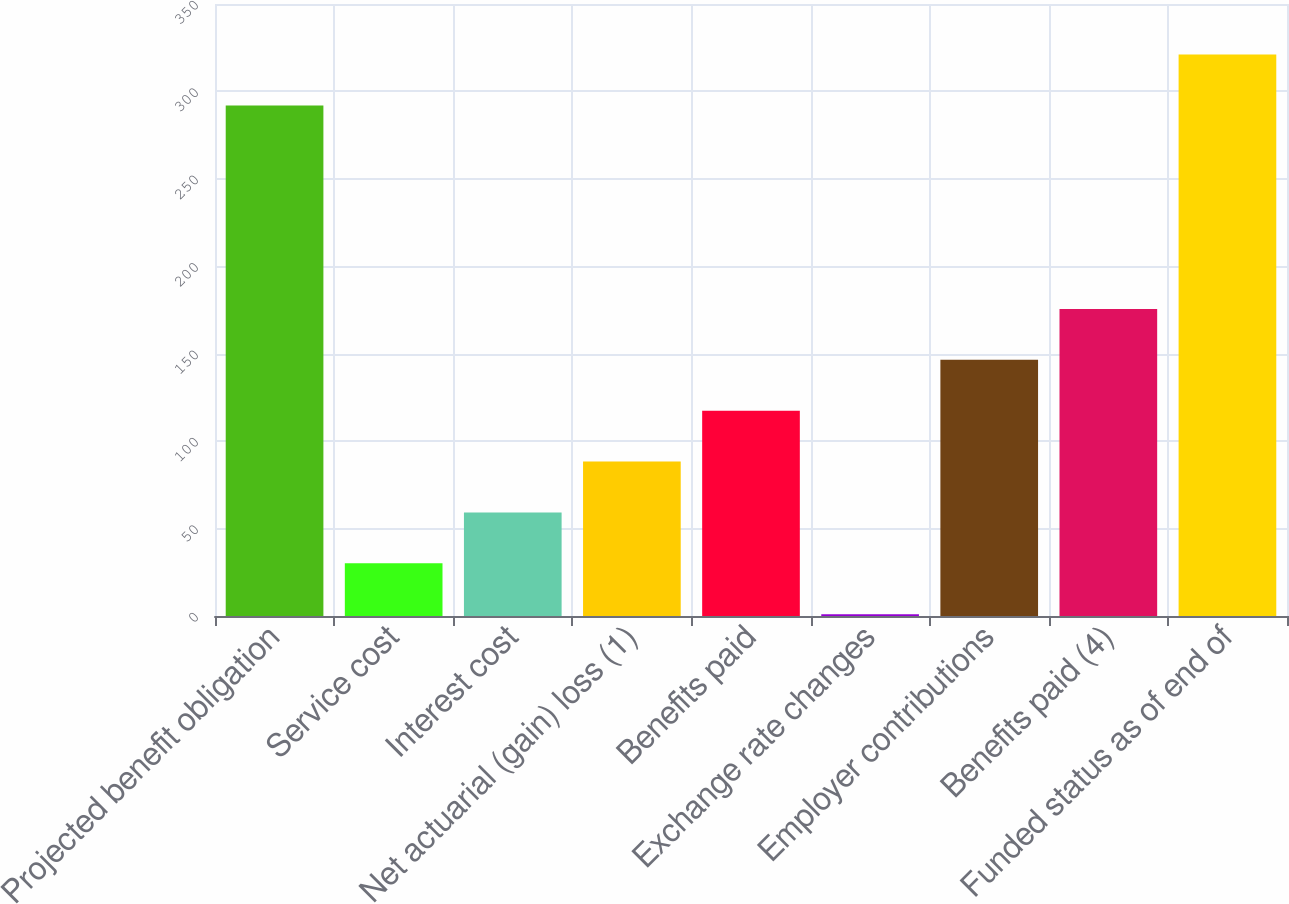<chart> <loc_0><loc_0><loc_500><loc_500><bar_chart><fcel>Projected benefit obligation<fcel>Service cost<fcel>Interest cost<fcel>Net actuarial (gain) loss (1)<fcel>Benefits paid<fcel>Exchange rate changes<fcel>Employer contributions<fcel>Benefits paid (4)<fcel>Funded status as of end of<nl><fcel>292<fcel>30.1<fcel>59.2<fcel>88.3<fcel>117.4<fcel>1<fcel>146.5<fcel>175.6<fcel>321.1<nl></chart> 